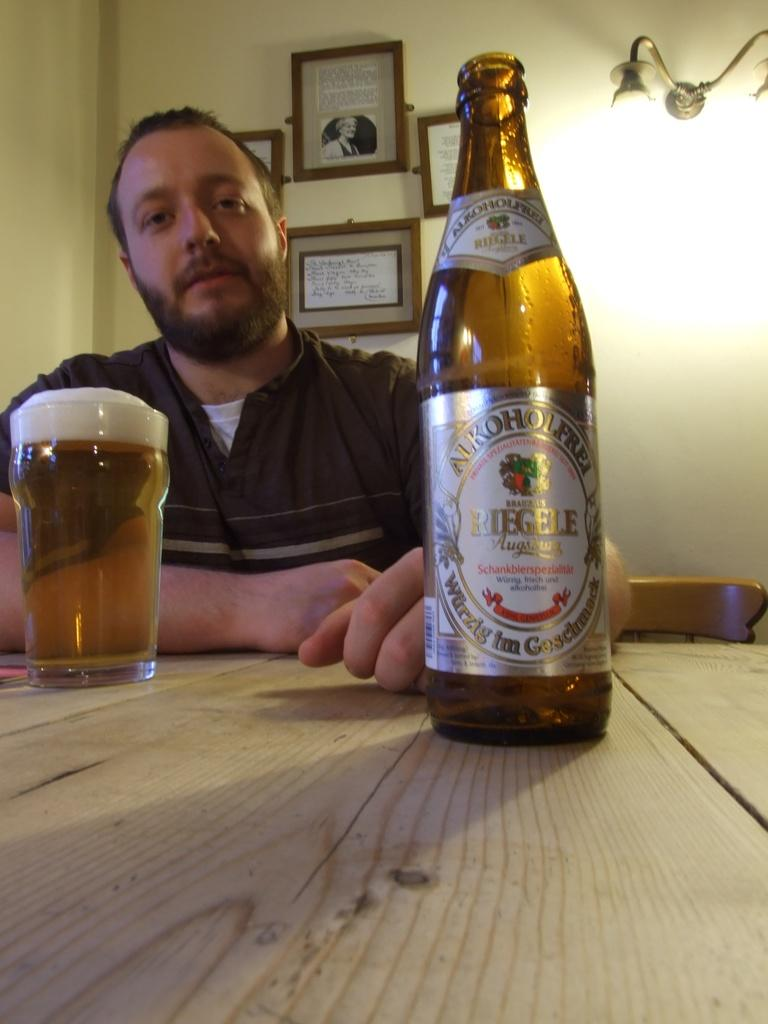<image>
Create a compact narrative representing the image presented. a beer bottle that says Riegele sits on a table 